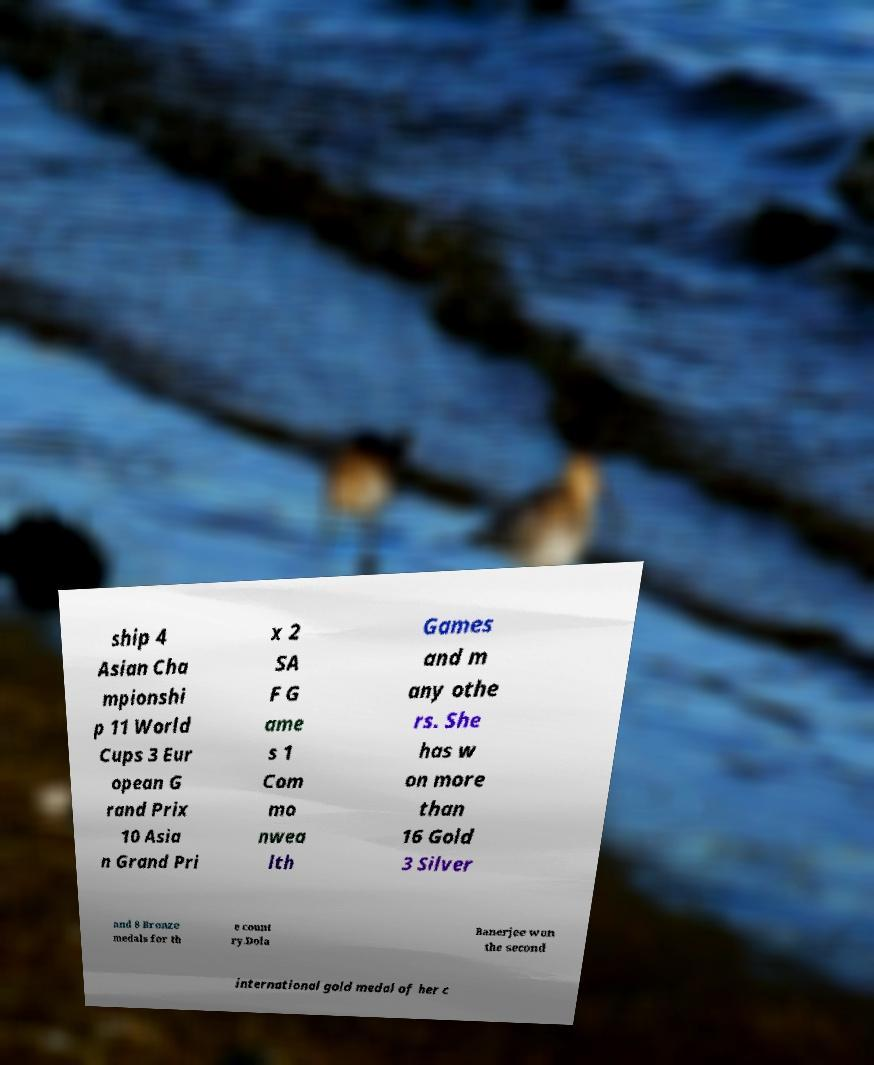Could you extract and type out the text from this image? ship 4 Asian Cha mpionshi p 11 World Cups 3 Eur opean G rand Prix 10 Asia n Grand Pri x 2 SA F G ame s 1 Com mo nwea lth Games and m any othe rs. She has w on more than 16 Gold 3 Silver and 8 Bronze medals for th e count ry.Dola Banerjee won the second international gold medal of her c 